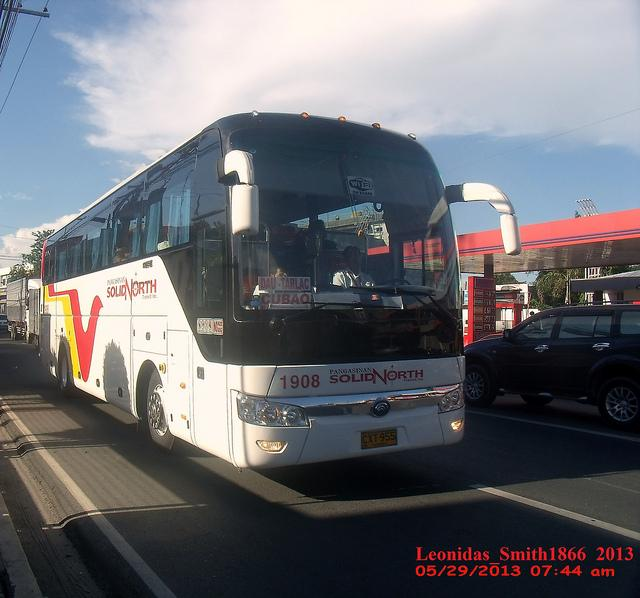What is the red building to the right of the bus used for? gas station 